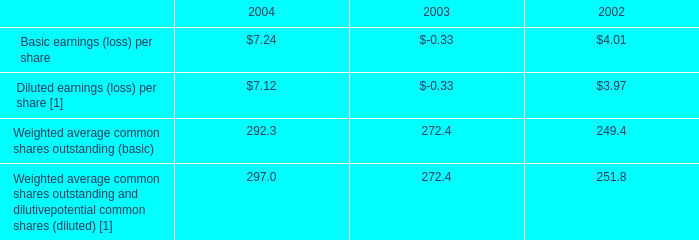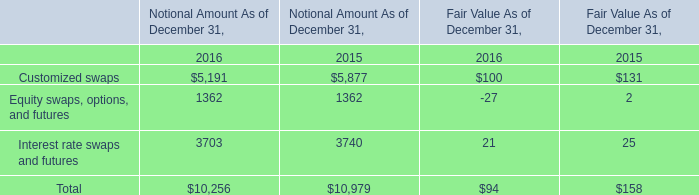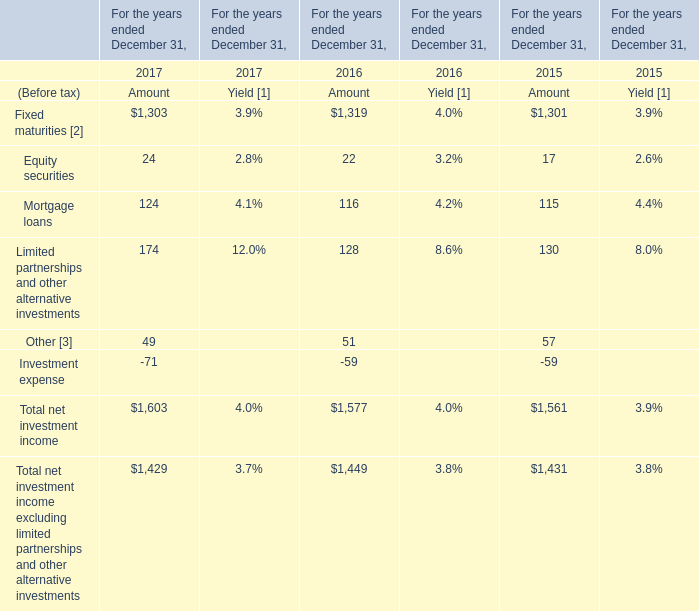What is the growing rate of Mortgage loans in the year with the most Equity securities? 
Computations: ((124 - 116) / 124)
Answer: 0.06452. 